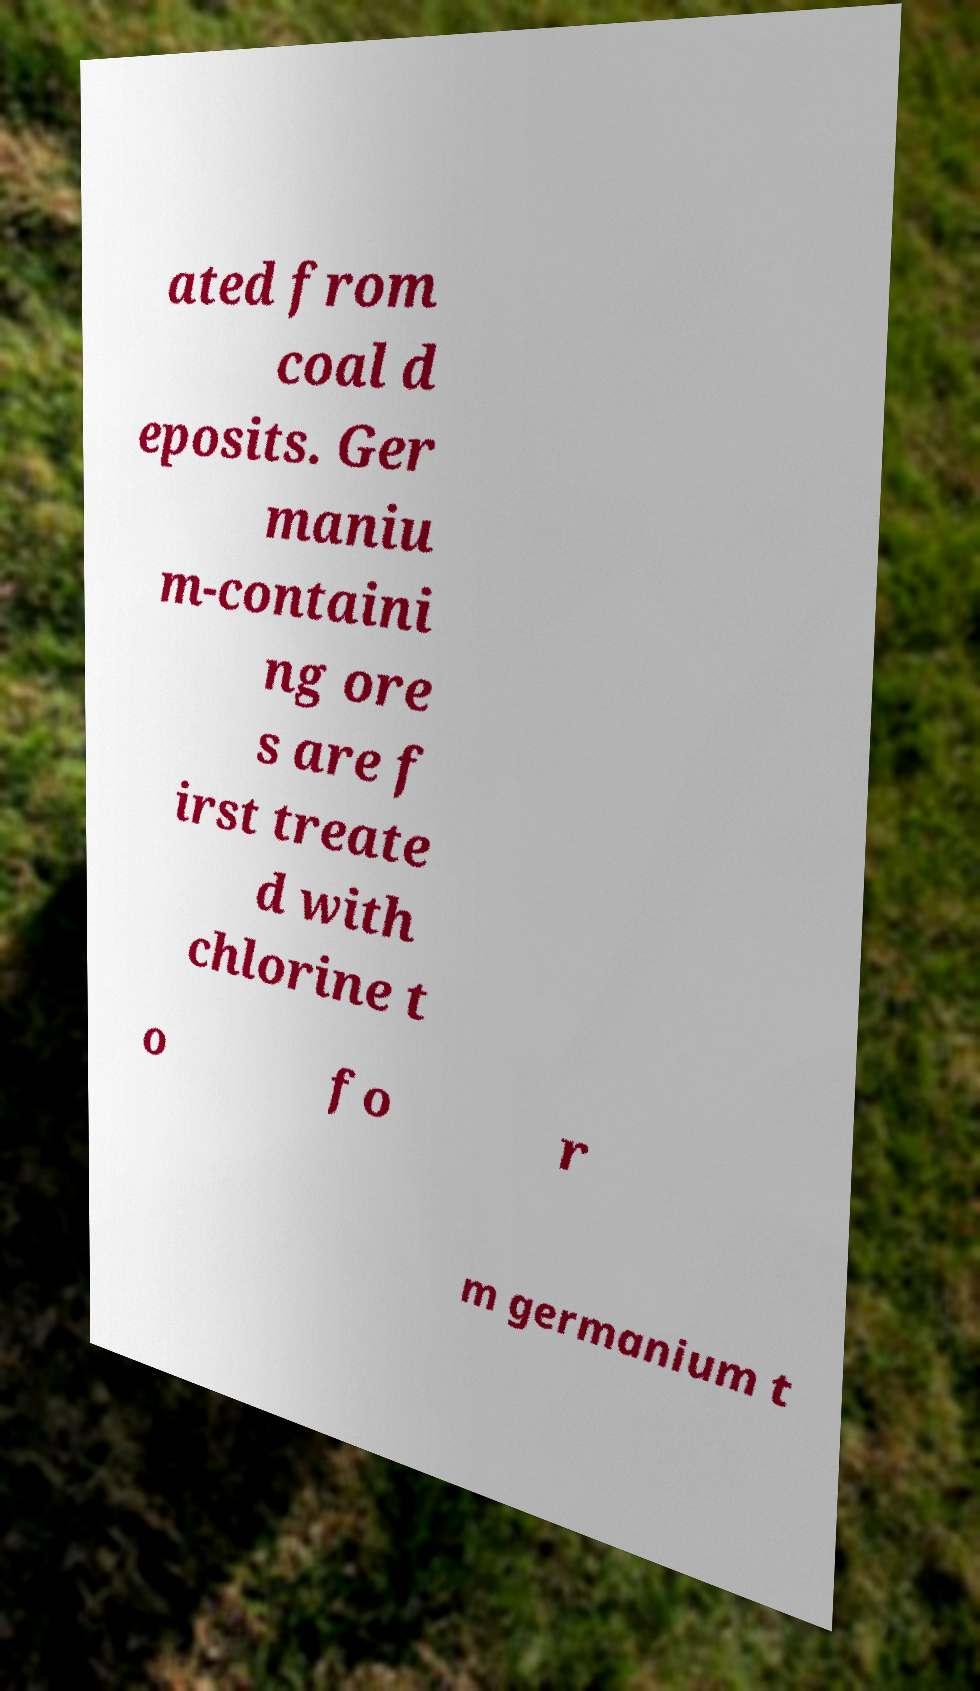For documentation purposes, I need the text within this image transcribed. Could you provide that? ated from coal d eposits. Ger maniu m-containi ng ore s are f irst treate d with chlorine t o fo r m germanium t 